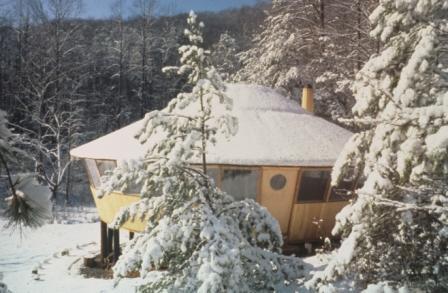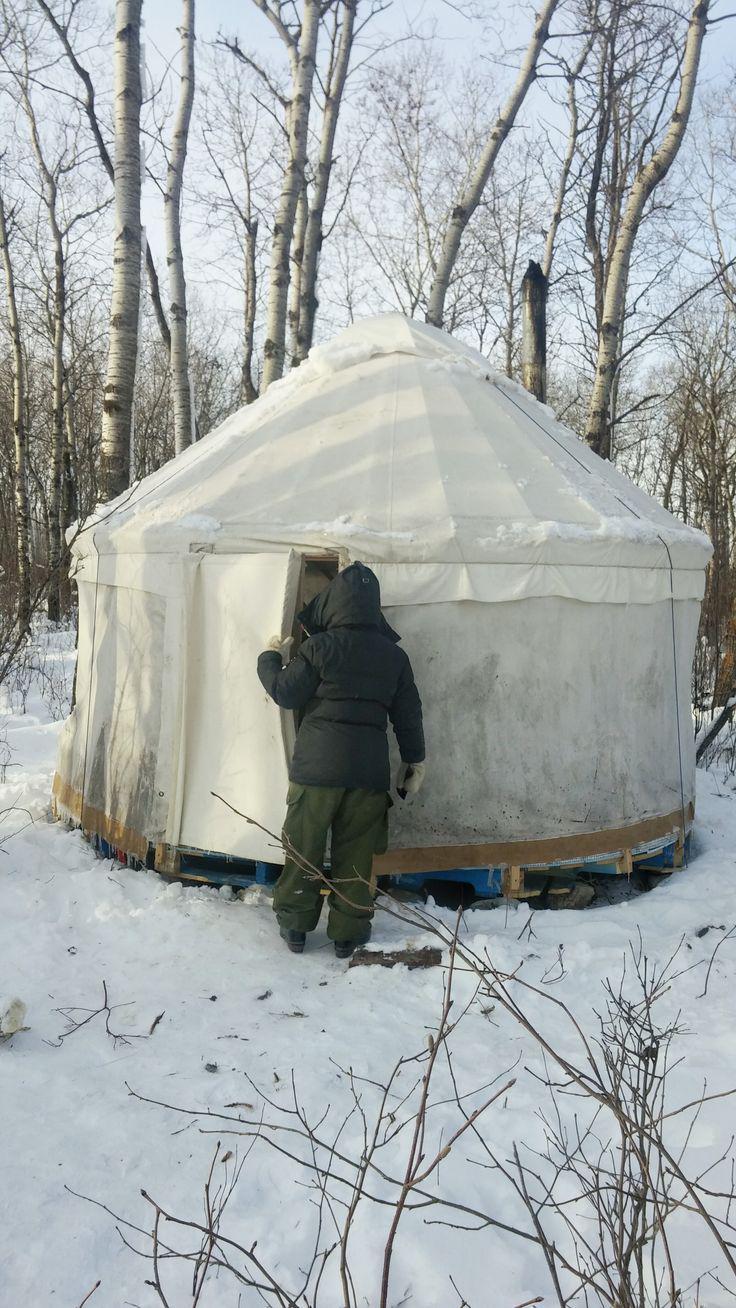The first image is the image on the left, the second image is the image on the right. Given the left and right images, does the statement "A stovepipe extends upward from the roof of the yurt in the image on the left." hold true? Answer yes or no. Yes. 